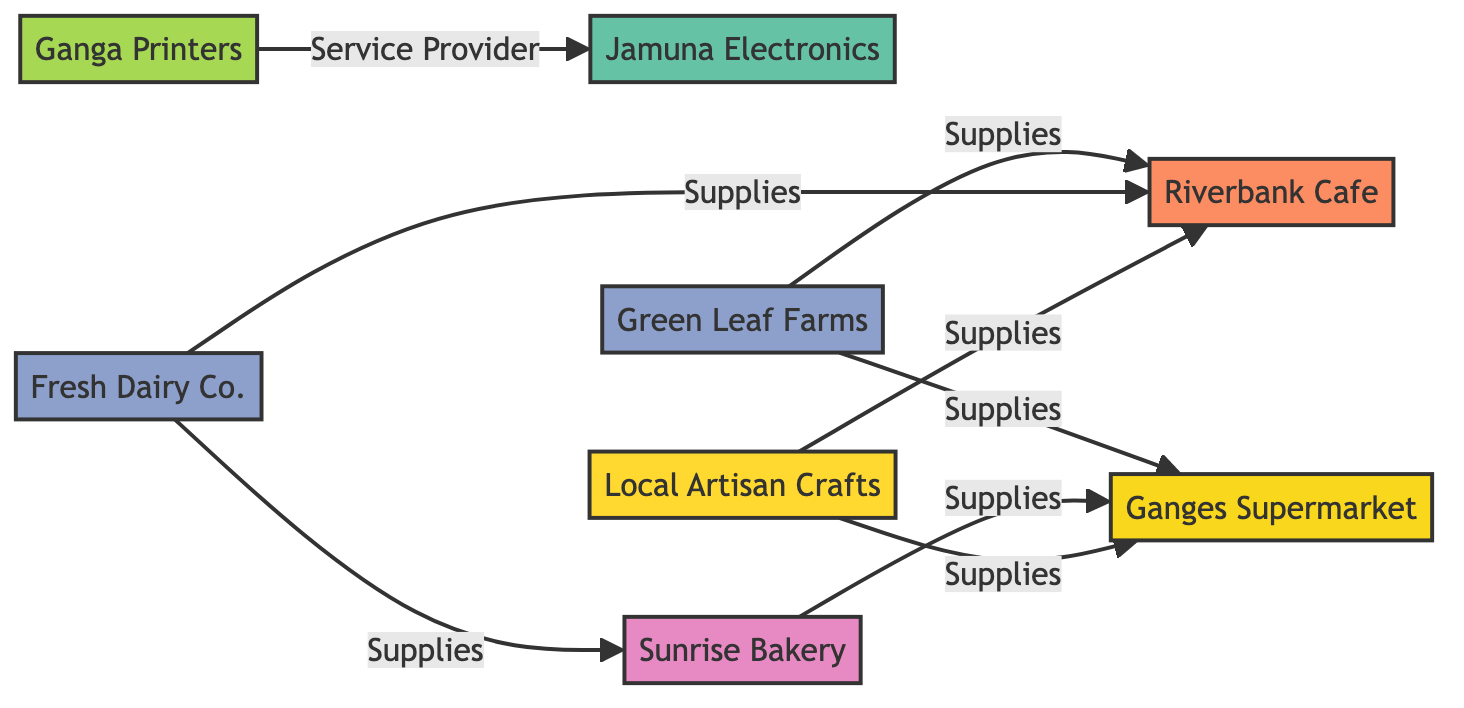What type of business is Ganges Supermarket? Ganges Supermarket is classified as a supermarket. This information is directly retrieved from the node description labeled "Ganges Supermarket."
Answer: Supermarket How many suppliers are represented in the diagram? The diagram includes two suppliers: Green Leaf Farms and Fresh Dairy Co. By counting the nodes of type "Supplier," we arrive at this number.
Answer: 2 Which restaurant is supplied by Fresh Dairy Co.? Fresh Dairy Co. supplies Riverbank Cafe, as indicated by the edge labeled "Supplies" connecting Fresh Dairy Co. to Riverbank Cafe.
Answer: Riverbank Cafe What is the relationship between Ganga Printers and Jamuna Electronics? Ganga Printers is the service provider for Jamuna Electronics. This relationship is specified in the edge labeled "Service Provider" connecting these two nodes.
Answer: Service Provider How many total edges are there in this network? By counting all edges connecting nodes in the diagram, we find there are a total of 8 connections. This involves looking at all supplied relationships and services represented in the edges.
Answer: 8 Which businesses does Green Leaf Farms supply? Green Leaf Farms supplies Ganges Supermarket and Riverbank Cafe, as shown by the edges connecting Green Leaf Farms to these two nodes with the "Supplies" relationship.
Answer: Ganges Supermarket and Riverbank Cafe Can you name a bakery in the diagram? Sunrise Bakery is identified as a bakery. This comes from the node labeled "Sunrise Bakery," which specifies its type as "Bakery."
Answer: Sunrise Bakery Who does Local Artisan Crafts supply? Local Artisan Crafts supplies both Ganges Supermarket and Riverbank Cafe, as indicated by the two edges labeled "Supplies" connecting Local Artisan Crafts to these two businesses.
Answer: Ganges Supermarket and Riverbank Cafe 